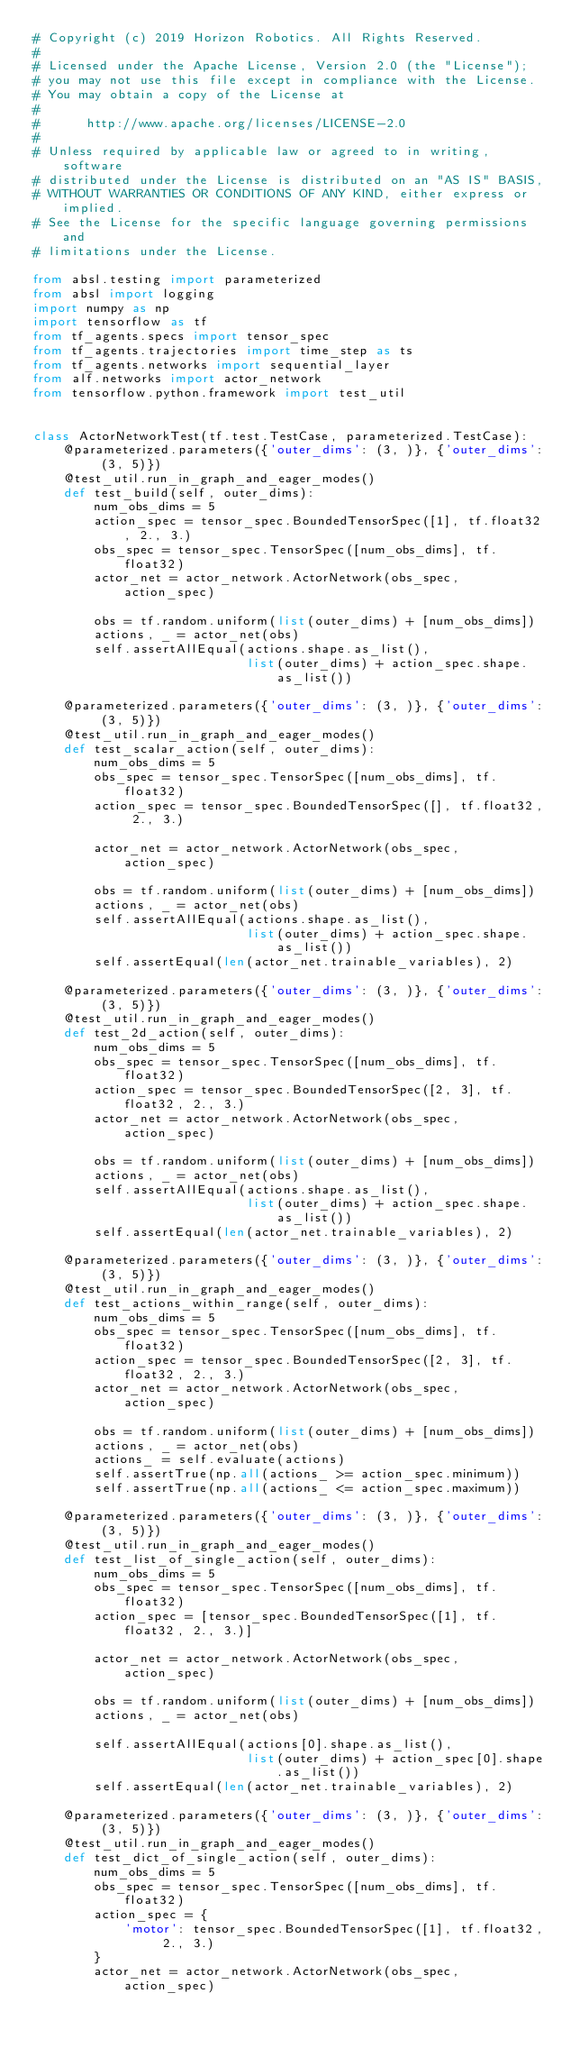Convert code to text. <code><loc_0><loc_0><loc_500><loc_500><_Python_># Copyright (c) 2019 Horizon Robotics. All Rights Reserved.
#
# Licensed under the Apache License, Version 2.0 (the "License");
# you may not use this file except in compliance with the License.
# You may obtain a copy of the License at
#
#      http://www.apache.org/licenses/LICENSE-2.0
#
# Unless required by applicable law or agreed to in writing, software
# distributed under the License is distributed on an "AS IS" BASIS,
# WITHOUT WARRANTIES OR CONDITIONS OF ANY KIND, either express or implied.
# See the License for the specific language governing permissions and
# limitations under the License.

from absl.testing import parameterized
from absl import logging
import numpy as np
import tensorflow as tf
from tf_agents.specs import tensor_spec
from tf_agents.trajectories import time_step as ts
from tf_agents.networks import sequential_layer
from alf.networks import actor_network
from tensorflow.python.framework import test_util


class ActorNetworkTest(tf.test.TestCase, parameterized.TestCase):
    @parameterized.parameters({'outer_dims': (3, )}, {'outer_dims': (3, 5)})
    @test_util.run_in_graph_and_eager_modes()
    def test_build(self, outer_dims):
        num_obs_dims = 5
        action_spec = tensor_spec.BoundedTensorSpec([1], tf.float32, 2., 3.)
        obs_spec = tensor_spec.TensorSpec([num_obs_dims], tf.float32)
        actor_net = actor_network.ActorNetwork(obs_spec, action_spec)

        obs = tf.random.uniform(list(outer_dims) + [num_obs_dims])
        actions, _ = actor_net(obs)
        self.assertAllEqual(actions.shape.as_list(),
                            list(outer_dims) + action_spec.shape.as_list())

    @parameterized.parameters({'outer_dims': (3, )}, {'outer_dims': (3, 5)})
    @test_util.run_in_graph_and_eager_modes()
    def test_scalar_action(self, outer_dims):
        num_obs_dims = 5
        obs_spec = tensor_spec.TensorSpec([num_obs_dims], tf.float32)
        action_spec = tensor_spec.BoundedTensorSpec([], tf.float32, 2., 3.)

        actor_net = actor_network.ActorNetwork(obs_spec, action_spec)

        obs = tf.random.uniform(list(outer_dims) + [num_obs_dims])
        actions, _ = actor_net(obs)
        self.assertAllEqual(actions.shape.as_list(),
                            list(outer_dims) + action_spec.shape.as_list())
        self.assertEqual(len(actor_net.trainable_variables), 2)

    @parameterized.parameters({'outer_dims': (3, )}, {'outer_dims': (3, 5)})
    @test_util.run_in_graph_and_eager_modes()
    def test_2d_action(self, outer_dims):
        num_obs_dims = 5
        obs_spec = tensor_spec.TensorSpec([num_obs_dims], tf.float32)
        action_spec = tensor_spec.BoundedTensorSpec([2, 3], tf.float32, 2., 3.)
        actor_net = actor_network.ActorNetwork(obs_spec, action_spec)

        obs = tf.random.uniform(list(outer_dims) + [num_obs_dims])
        actions, _ = actor_net(obs)
        self.assertAllEqual(actions.shape.as_list(),
                            list(outer_dims) + action_spec.shape.as_list())
        self.assertEqual(len(actor_net.trainable_variables), 2)

    @parameterized.parameters({'outer_dims': (3, )}, {'outer_dims': (3, 5)})
    @test_util.run_in_graph_and_eager_modes()
    def test_actions_within_range(self, outer_dims):
        num_obs_dims = 5
        obs_spec = tensor_spec.TensorSpec([num_obs_dims], tf.float32)
        action_spec = tensor_spec.BoundedTensorSpec([2, 3], tf.float32, 2., 3.)
        actor_net = actor_network.ActorNetwork(obs_spec, action_spec)

        obs = tf.random.uniform(list(outer_dims) + [num_obs_dims])
        actions, _ = actor_net(obs)
        actions_ = self.evaluate(actions)
        self.assertTrue(np.all(actions_ >= action_spec.minimum))
        self.assertTrue(np.all(actions_ <= action_spec.maximum))

    @parameterized.parameters({'outer_dims': (3, )}, {'outer_dims': (3, 5)})
    @test_util.run_in_graph_and_eager_modes()
    def test_list_of_single_action(self, outer_dims):
        num_obs_dims = 5
        obs_spec = tensor_spec.TensorSpec([num_obs_dims], tf.float32)
        action_spec = [tensor_spec.BoundedTensorSpec([1], tf.float32, 2., 3.)]

        actor_net = actor_network.ActorNetwork(obs_spec, action_spec)

        obs = tf.random.uniform(list(outer_dims) + [num_obs_dims])
        actions, _ = actor_net(obs)

        self.assertAllEqual(actions[0].shape.as_list(),
                            list(outer_dims) + action_spec[0].shape.as_list())
        self.assertEqual(len(actor_net.trainable_variables), 2)

    @parameterized.parameters({'outer_dims': (3, )}, {'outer_dims': (3, 5)})
    @test_util.run_in_graph_and_eager_modes()
    def test_dict_of_single_action(self, outer_dims):
        num_obs_dims = 5
        obs_spec = tensor_spec.TensorSpec([num_obs_dims], tf.float32)
        action_spec = {
            'motor': tensor_spec.BoundedTensorSpec([1], tf.float32, 2., 3.)
        }
        actor_net = actor_network.ActorNetwork(obs_spec, action_spec)
</code> 